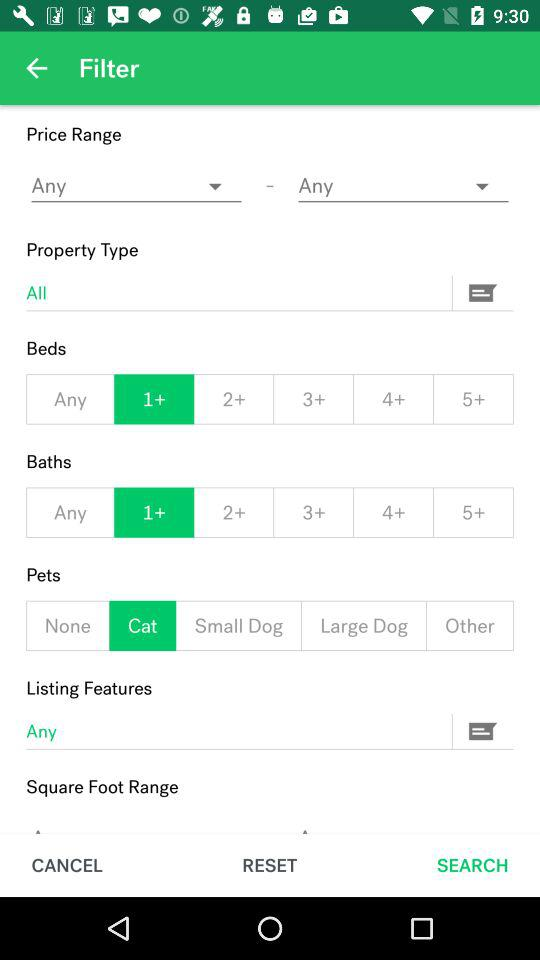Which tab is currently selected? The selected tab is "SEARCH". 